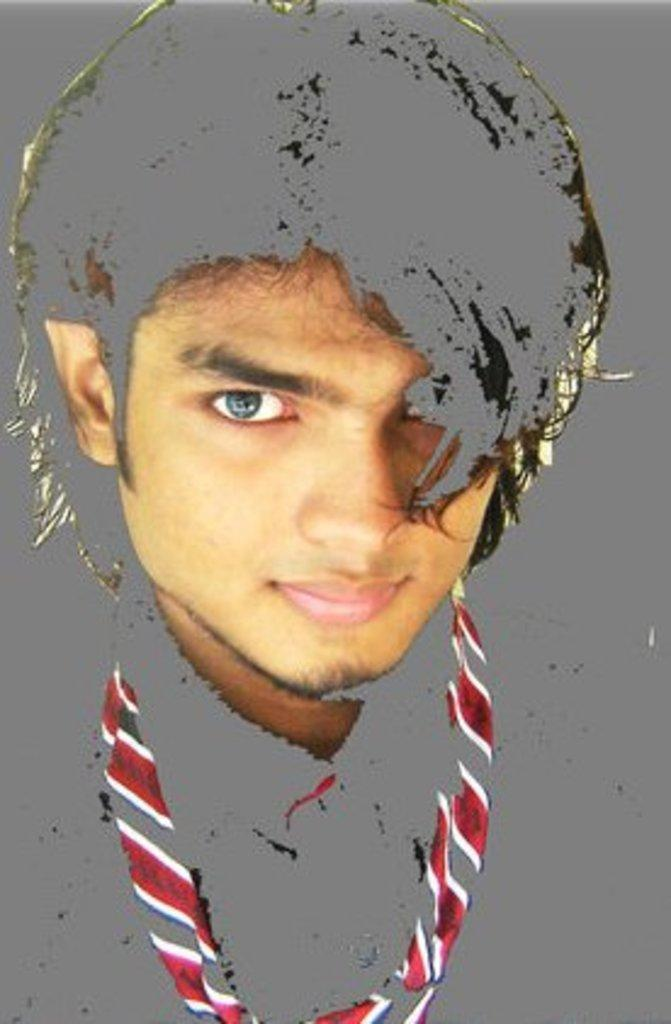Who is present in the image? There is a man in the image. What can be seen in addition to the man? There is a sketch in the image. How many sisters are present in the image? There are no sisters mentioned or visible in the image. What type of ornament is hanging from the man's neck in the image? There is no ornament visible around the man's neck in the image. 